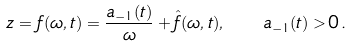<formula> <loc_0><loc_0><loc_500><loc_500>z = f ( \omega , t ) = \frac { a _ { - 1 } ( t ) } { \omega } + \hat { f } ( \omega , t ) , \quad a _ { - 1 } ( t ) > 0 \, .</formula> 